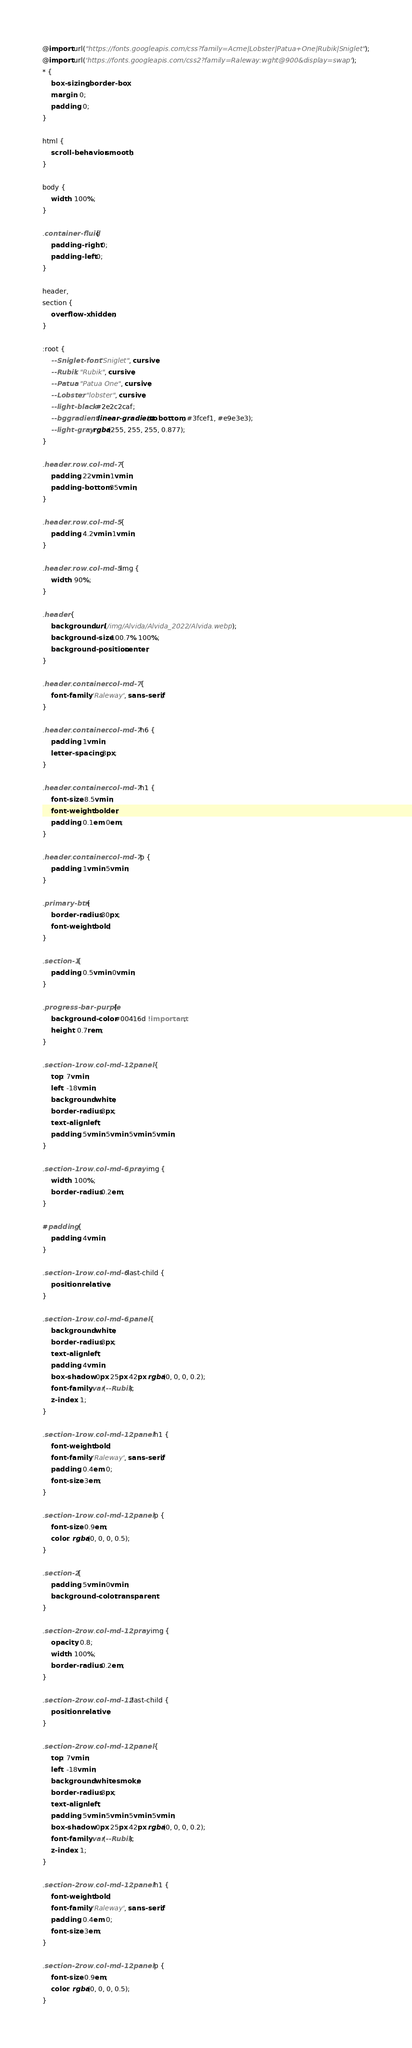Convert code to text. <code><loc_0><loc_0><loc_500><loc_500><_CSS_>@import url("https://fonts.googleapis.com/css?family=Acme|Lobster|Patua+One|Rubik|Sniglet");
@import url('https://fonts.googleapis.com/css2?family=Raleway:wght@900&display=swap');
* {
    box-sizing: border-box;
    margin: 0;
    padding: 0;
}

html {
    scroll-behavior: smooth;
}

body {
    width: 100%;
}

.container-fluid {
    padding-right: 0;
    padding-left: 0;
}

header,
section {
    overflow-x: hidden;
}

:root {
    --Sniglet-font: "Sniglet", cursive;
    --Rubik: "Rubik", cursive;
    --Patua: "Patua One", cursive;
    --Lobster: "lobster", cursive;
    --light-black: #2e2c2caf;
    --bggradient: linear-gradient(to bottom, #3fcef1, #e9e3e3);
    --light-gray: rgba(255, 255, 255, 0.877);
}

.header .row .col-md-7 {
    padding: 22vmin 1vmin;
    padding-bottom: 35vmin;
}

.header .row .col-md-5 {
    padding: 4.2vmin 1vmin;
}

.header .row .col-md-5 img {
    width: 90%;
}

.header {
    background: url(/img/Alvida/Alvida_2022/Alvida.webp);
    background-size: 100.7% 100%;
    background-position: center;
}

.header .container .col-md-7 {
    font-family: 'Raleway', sans-serif;
}

.header .container .col-md-7 h6 {
    padding: 1vmin;
    letter-spacing: 3px;
}

.header .container .col-md-7 h1 {
    font-size: 8.5vmin;
    font-weight: bolder;
    padding: 0.1em 0em;
}

.header .container .col-md-7 p {
    padding: 1vmin 5vmin;
}

.primary-btn {
    border-radius: 30px;
    font-weight: bold;
}

.section-1 {
    padding: 0.5vmin 0vmin;
}

.progress-bar-purple {
    background-color: #00416d !important;
    height: 0.7rem;
}

.section-1 .row .col-md-12 .panel {
    top: 7vmin;
    left: -18vmin;
    background: white;
    border-radius: 3px;
    text-align: left;
    padding: 5vmin 5vmin 5vmin 5vmin;
}

.section-1 .row .col-md-6 .pray img {
    width: 100%;
    border-radius: 0.2em;
}

#padding {
    padding: 4vmin;
}

.section-1 .row .col-md-6:last-child {
    position: relative;
}

.section-1 .row .col-md-6 .panel {
    background: white;
    border-radius: 3px;
    text-align: left;
    padding: 4vmin;
    box-shadow: 0px 25px 42px rgba(0, 0, 0, 0.2);
    font-family: var(--Rubik);
    z-index: 1;
}

.section-1 .row .col-md-12 .panel h1 {
    font-weight: bold;
    font-family: 'Raleway', sans-serif;
    padding: 0.4em 0;
    font-size: 3em;
}

.section-1 .row .col-md-12 .panel p {
    font-size: 0.9em;
    color: rgba(0, 0, 0, 0.5);
}

.section-2 {
    padding: 5vmin 0vmin;
    background-color: transparent;
}

.section-2 .row .col-md-12 .pray img {
    opacity: 0.8;
    width: 100%;
    border-radius: 0.2em;
}

.section-2 .row .col-md-12:last-child {
    position: relative;
}

.section-2 .row .col-md-12 .panel {
    top: 7vmin;
    left: -18vmin;
    background: whitesmoke;
    border-radius: 3px;
    text-align: left;
    padding: 5vmin 5vmin 5vmin 5vmin;
    box-shadow: 0px 25px 42px rgba(0, 0, 0, 0.2);
    font-family: var(--Rubik);
    z-index: 1;
}

.section-2 .row .col-md-12 .panel h1 {
    font-weight: bold;
    font-family: 'Raleway', sans-serif;
    padding: 0.4em 0;
    font-size: 3em;
}

.section-2 .row .col-md-12 .panel p {
    font-size: 0.9em;
    color: rgba(0, 0, 0, 0.5);
}
</code> 